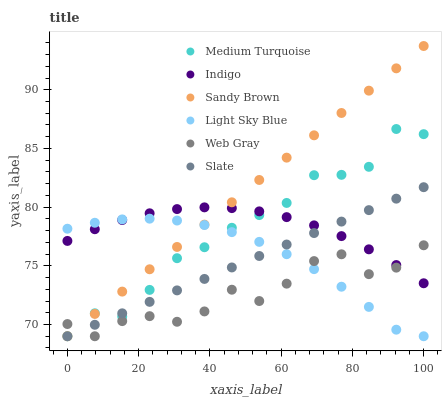Does Web Gray have the minimum area under the curve?
Answer yes or no. Yes. Does Sandy Brown have the maximum area under the curve?
Answer yes or no. Yes. Does Indigo have the minimum area under the curve?
Answer yes or no. No. Does Indigo have the maximum area under the curve?
Answer yes or no. No. Is Slate the smoothest?
Answer yes or no. Yes. Is Web Gray the roughest?
Answer yes or no. Yes. Is Indigo the smoothest?
Answer yes or no. No. Is Indigo the roughest?
Answer yes or no. No. Does Web Gray have the lowest value?
Answer yes or no. Yes. Does Indigo have the lowest value?
Answer yes or no. No. Does Sandy Brown have the highest value?
Answer yes or no. Yes. Does Indigo have the highest value?
Answer yes or no. No. Does Web Gray intersect Sandy Brown?
Answer yes or no. Yes. Is Web Gray less than Sandy Brown?
Answer yes or no. No. Is Web Gray greater than Sandy Brown?
Answer yes or no. No. 